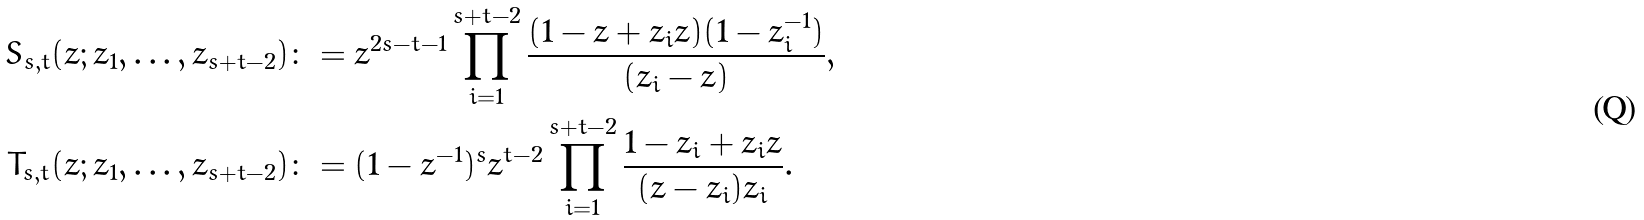Convert formula to latex. <formula><loc_0><loc_0><loc_500><loc_500>S _ { s , t } ( z ; z _ { 1 } , \dots , z _ { s + t - 2 } ) & \colon = z ^ { 2 s - t - 1 } \prod _ { i = 1 } ^ { s + t - 2 } \frac { ( 1 - z + z _ { i } z ) ( 1 - z _ { i } ^ { - 1 } ) } { ( z _ { i } - z ) } , \\ T _ { s , t } ( z ; z _ { 1 } , \dots , z _ { s + t - 2 } ) & \colon = ( 1 - z ^ { - 1 } ) ^ { s } z ^ { t - 2 } \prod _ { i = 1 } ^ { s + t - 2 } \frac { 1 - z _ { i } + z _ { i } z } { ( z - z _ { i } ) z _ { i } } .</formula> 